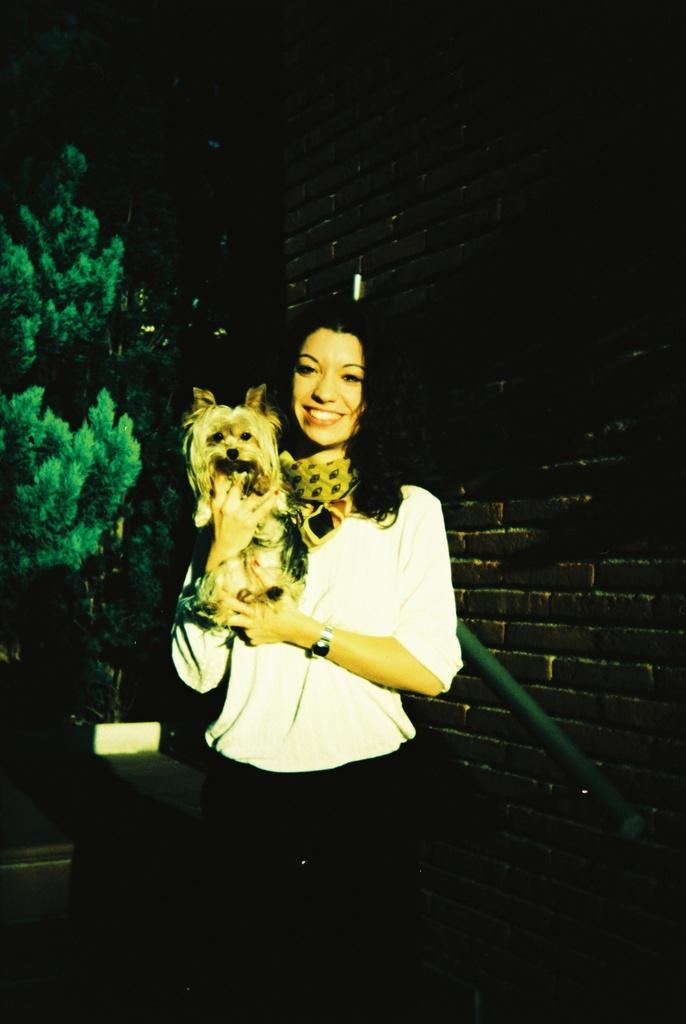What is the woman in the image doing? The woman is standing in the image and holding a dog. What can be seen behind the woman in the image? There is a black color brick wall and trees in the background of the image. What is the color of the trees in the image? The trees are green in color. What type of control system is the woman using to operate the tank in the image? There is no tank present in the image; the woman is holding a dog. How many vans are visible in the image? There are no vans visible in the image. 